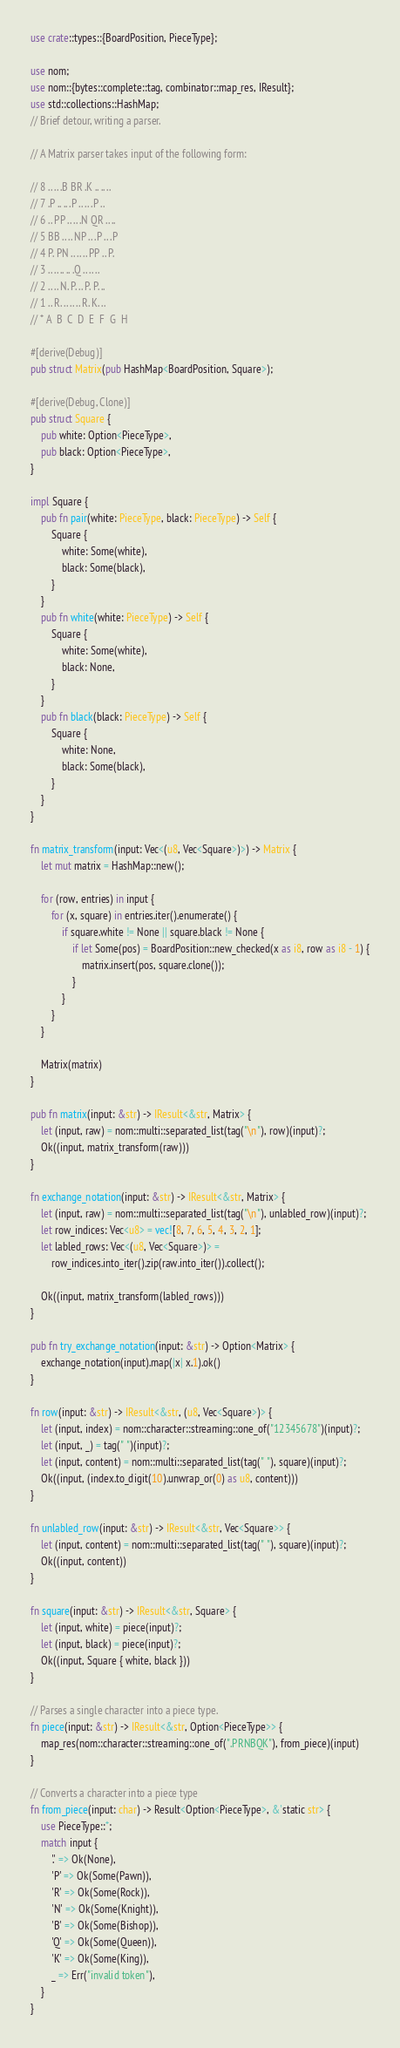Convert code to text. <code><loc_0><loc_0><loc_500><loc_500><_Rust_>use crate::types::{BoardPosition, PieceType};

use nom;
use nom::{bytes::complete::tag, combinator::map_res, IResult};
use std::collections::HashMap;
// Brief detour, writing a parser.

// A Matrix parser takes input of the following form:

// 8 .. .. .B BR .K .. .. ..
// 7 .P .. .. .P .. .. .P ..
// 6 .. PP .. .. .N QR .. ..
// 5 BB .. .. NP .. .P .. .P
// 4 P. PN .. .. .. PP .. P.
// 3 .. .. .. .. .Q .. .. ..
// 2 .. .. N. P. .. P. P. ..
// 1 .. R. .. .. .. R. K. ..
// * A  B  C  D  E  F  G  H

#[derive(Debug)]
pub struct Matrix(pub HashMap<BoardPosition, Square>);

#[derive(Debug, Clone)]
pub struct Square {
    pub white: Option<PieceType>,
    pub black: Option<PieceType>,
}

impl Square {
    pub fn pair(white: PieceType, black: PieceType) -> Self {
        Square {
            white: Some(white),
            black: Some(black),
        }
    }
    pub fn white(white: PieceType) -> Self {
        Square {
            white: Some(white),
            black: None,
        }
    }
    pub fn black(black: PieceType) -> Self {
        Square {
            white: None,
            black: Some(black),
        }
    }
}

fn matrix_transform(input: Vec<(u8, Vec<Square>)>) -> Matrix {
    let mut matrix = HashMap::new();

    for (row, entries) in input {
        for (x, square) in entries.iter().enumerate() {
            if square.white != None || square.black != None {
                if let Some(pos) = BoardPosition::new_checked(x as i8, row as i8 - 1) {
                    matrix.insert(pos, square.clone());
                }
            }
        }
    }

    Matrix(matrix)
}

pub fn matrix(input: &str) -> IResult<&str, Matrix> {
    let (input, raw) = nom::multi::separated_list(tag("\n"), row)(input)?;
    Ok((input, matrix_transform(raw)))
}

fn exchange_notation(input: &str) -> IResult<&str, Matrix> {
    let (input, raw) = nom::multi::separated_list(tag("\n"), unlabled_row)(input)?;
    let row_indices: Vec<u8> = vec![8, 7, 6, 5, 4, 3, 2, 1];
    let labled_rows: Vec<(u8, Vec<Square>)> =
        row_indices.into_iter().zip(raw.into_iter()).collect();

    Ok((input, matrix_transform(labled_rows)))
}

pub fn try_exchange_notation(input: &str) -> Option<Matrix> {
    exchange_notation(input).map(|x| x.1).ok()
}

fn row(input: &str) -> IResult<&str, (u8, Vec<Square>)> {
    let (input, index) = nom::character::streaming::one_of("12345678")(input)?;
    let (input, _) = tag(" ")(input)?;
    let (input, content) = nom::multi::separated_list(tag(" "), square)(input)?;
    Ok((input, (index.to_digit(10).unwrap_or(0) as u8, content)))
}

fn unlabled_row(input: &str) -> IResult<&str, Vec<Square>> {
    let (input, content) = nom::multi::separated_list(tag(" "), square)(input)?;
    Ok((input, content))
}

fn square(input: &str) -> IResult<&str, Square> {
    let (input, white) = piece(input)?;
    let (input, black) = piece(input)?;
    Ok((input, Square { white, black }))
}

// Parses a single character into a piece type.
fn piece(input: &str) -> IResult<&str, Option<PieceType>> {
    map_res(nom::character::streaming::one_of(".PRNBQK"), from_piece)(input)
}

// Converts a character into a piece type
fn from_piece(input: char) -> Result<Option<PieceType>, &'static str> {
    use PieceType::*;
    match input {
        '.' => Ok(None),
        'P' => Ok(Some(Pawn)),
        'R' => Ok(Some(Rock)),
        'N' => Ok(Some(Knight)),
        'B' => Ok(Some(Bishop)),
        'Q' => Ok(Some(Queen)),
        'K' => Ok(Some(King)),
        _ => Err("invalid token"),
    }
}
</code> 